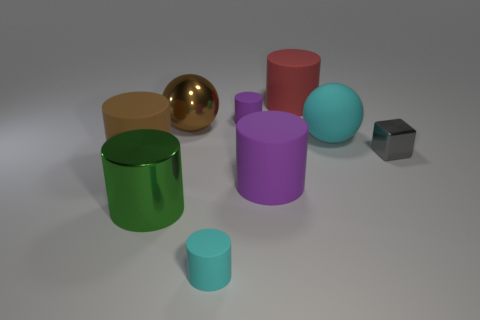There is a cylinder that is the same color as the metal sphere; what size is it?
Make the answer very short. Large. Is the material of the big cyan thing the same as the red cylinder?
Keep it short and to the point. Yes. Is there a red object that is on the right side of the big brown metallic object that is to the left of the large purple cylinder?
Offer a terse response. Yes. Are there any big matte objects of the same shape as the tiny purple matte object?
Your answer should be compact. Yes. What material is the ball left of the tiny cyan rubber cylinder left of the big cyan thing?
Ensure brevity in your answer.  Metal. What is the size of the gray object?
Provide a succinct answer. Small. What is the size of the cyan cylinder that is the same material as the big cyan thing?
Provide a short and direct response. Small. Do the purple matte cylinder behind the gray shiny thing and the gray metal block have the same size?
Your answer should be very brief. Yes. There is a big cyan matte thing that is behind the small matte cylinder in front of the large brown thing that is left of the shiny sphere; what is its shape?
Make the answer very short. Sphere. What number of objects are either tiny cyan metallic spheres or cylinders in front of the big red thing?
Your answer should be very brief. 5. 